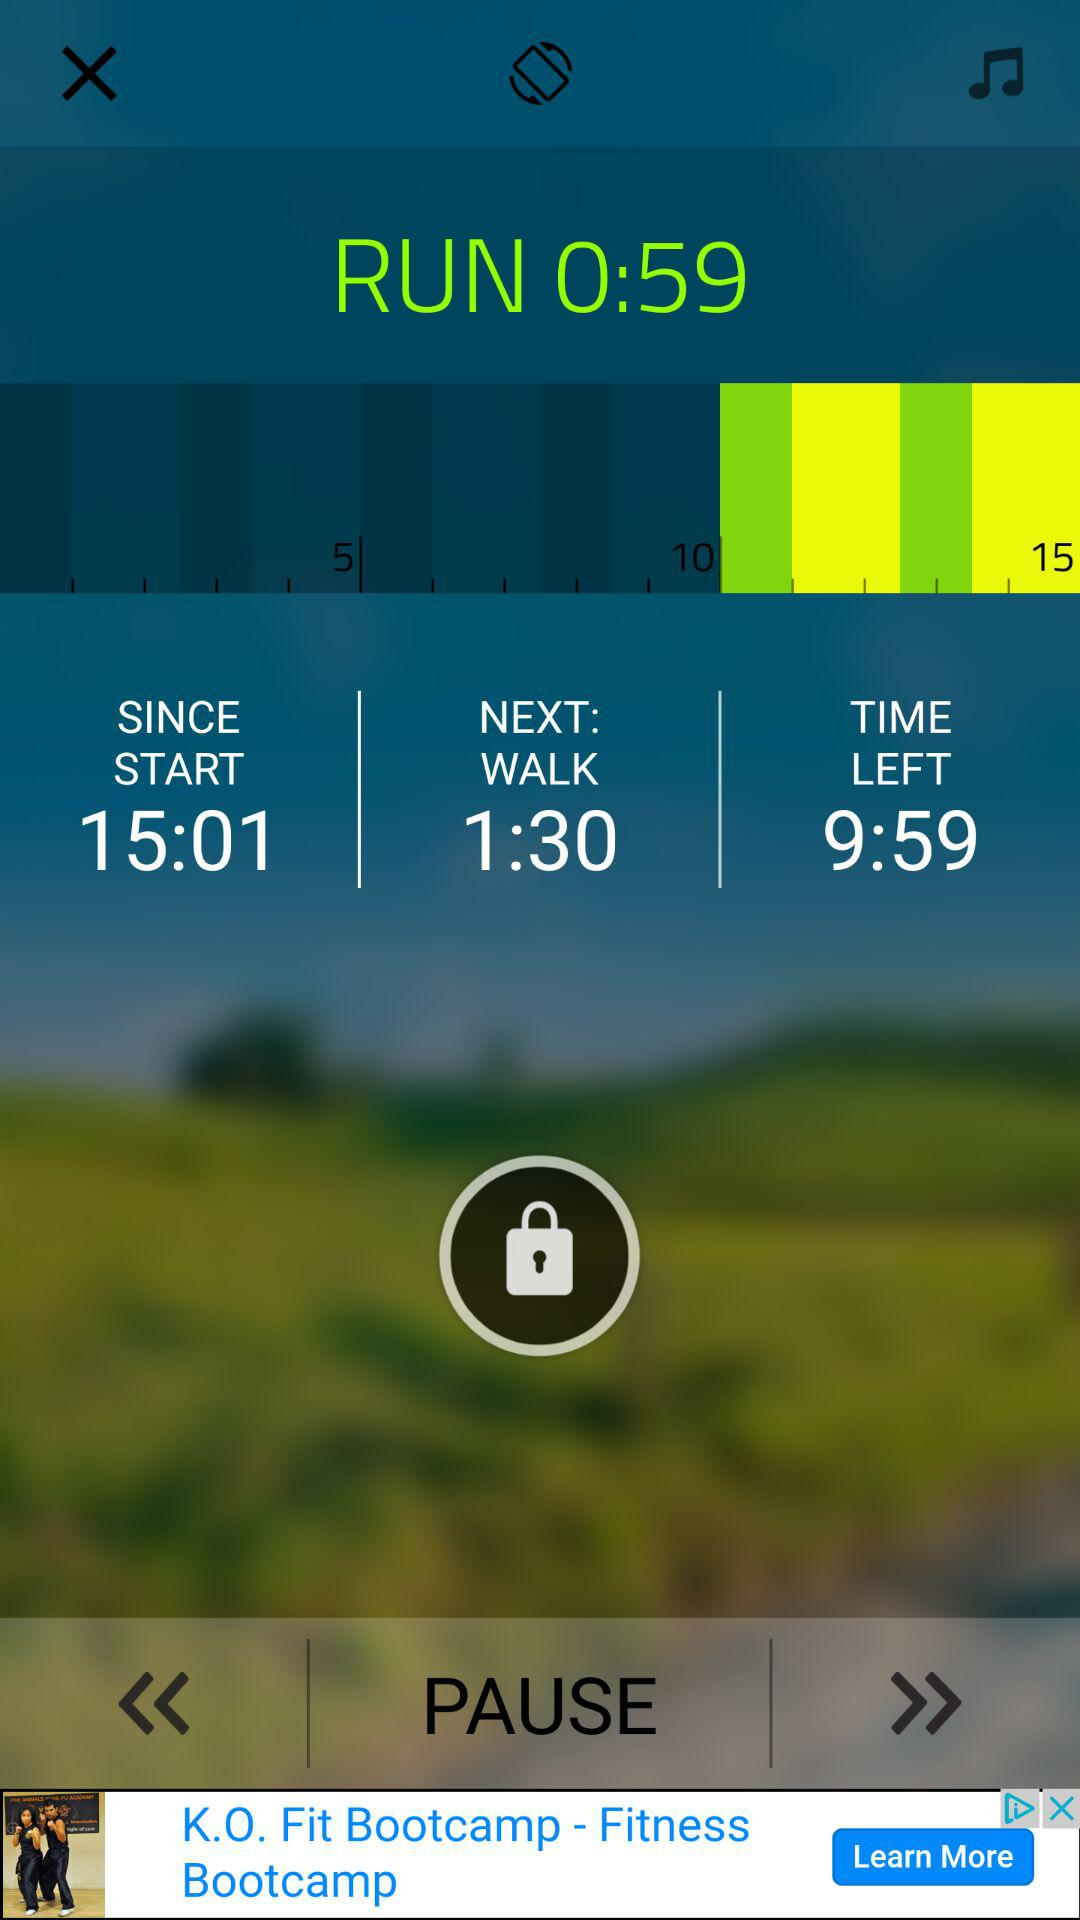What is the total running time? The total running time is 59 seconds. 